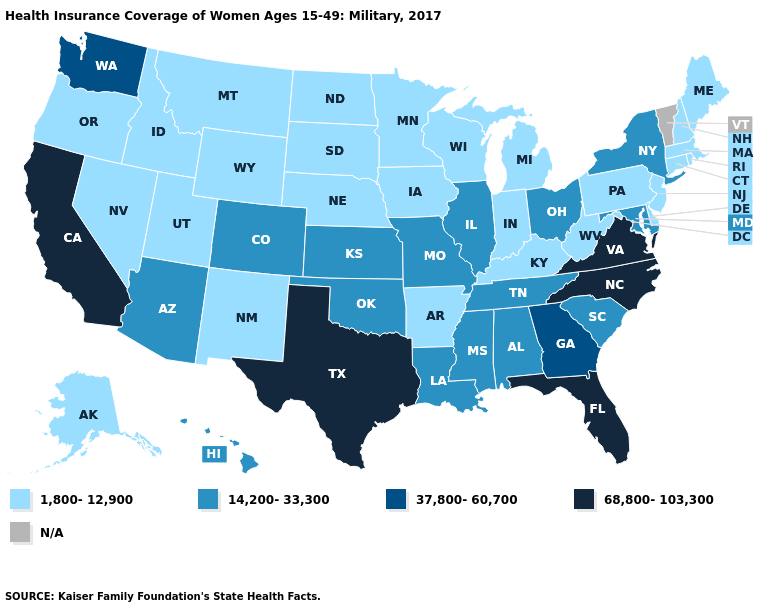Among the states that border Virginia , does North Carolina have the highest value?
Answer briefly. Yes. Name the states that have a value in the range N/A?
Give a very brief answer. Vermont. What is the highest value in the USA?
Short answer required. 68,800-103,300. Does the first symbol in the legend represent the smallest category?
Quick response, please. Yes. What is the lowest value in states that border Wyoming?
Write a very short answer. 1,800-12,900. Name the states that have a value in the range 14,200-33,300?
Short answer required. Alabama, Arizona, Colorado, Hawaii, Illinois, Kansas, Louisiana, Maryland, Mississippi, Missouri, New York, Ohio, Oklahoma, South Carolina, Tennessee. Does the map have missing data?
Keep it brief. Yes. Name the states that have a value in the range N/A?
Write a very short answer. Vermont. Among the states that border Missouri , does Illinois have the highest value?
Write a very short answer. Yes. Among the states that border Kentucky , which have the highest value?
Short answer required. Virginia. Which states have the lowest value in the West?
Concise answer only. Alaska, Idaho, Montana, Nevada, New Mexico, Oregon, Utah, Wyoming. Does Wisconsin have the lowest value in the USA?
Concise answer only. Yes. Name the states that have a value in the range 14,200-33,300?
Short answer required. Alabama, Arizona, Colorado, Hawaii, Illinois, Kansas, Louisiana, Maryland, Mississippi, Missouri, New York, Ohio, Oklahoma, South Carolina, Tennessee. What is the value of Utah?
Keep it brief. 1,800-12,900. Does the map have missing data?
Be succinct. Yes. 